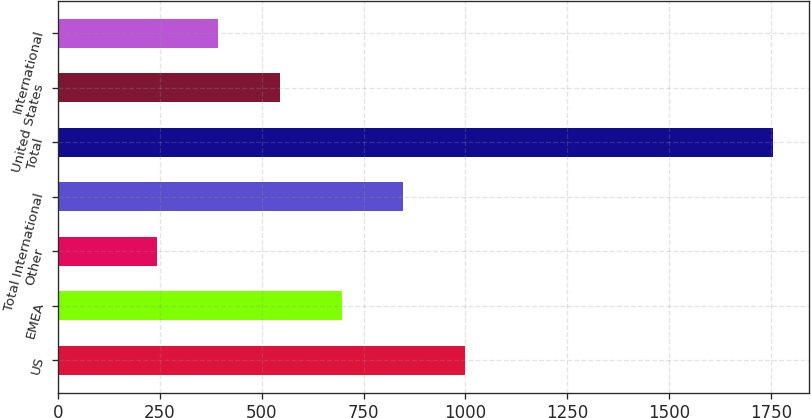<chart> <loc_0><loc_0><loc_500><loc_500><bar_chart><fcel>US<fcel>EMEA<fcel>Other<fcel>Total International<fcel>Total<fcel>United States<fcel>International<nl><fcel>998.8<fcel>696.16<fcel>242.2<fcel>847.48<fcel>1755.4<fcel>544.84<fcel>393.52<nl></chart> 